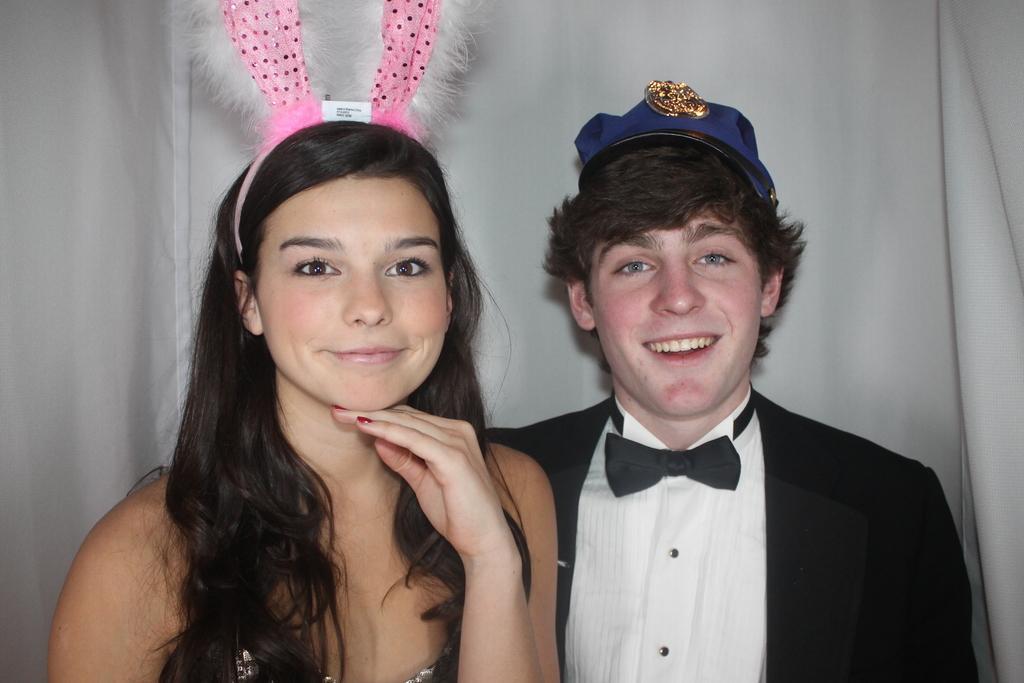Could you give a brief overview of what you see in this image? On the left side of the image a lady is present and wearing band. On the right side of the image a man is present and wearing hat. In the background of the image we can see a cloth. 